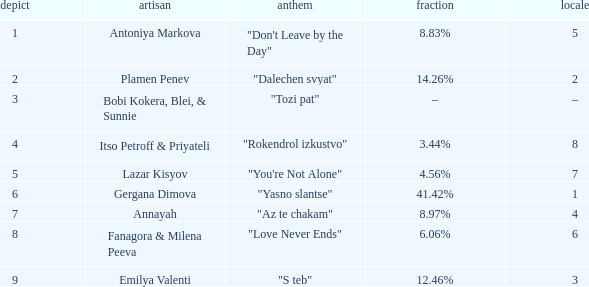Which Percentage has a Draw of 6? 41.42%. 